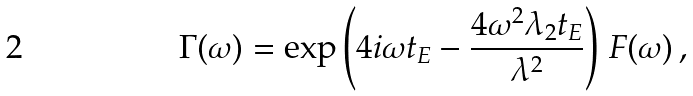Convert formula to latex. <formula><loc_0><loc_0><loc_500><loc_500>\Gamma ( \omega ) = \exp \left ( 4 i \omega t _ { E } - \frac { 4 \omega ^ { 2 } \lambda _ { 2 } t _ { E } } { \lambda ^ { 2 } } \right ) \, F ( \omega ) \, ,</formula> 